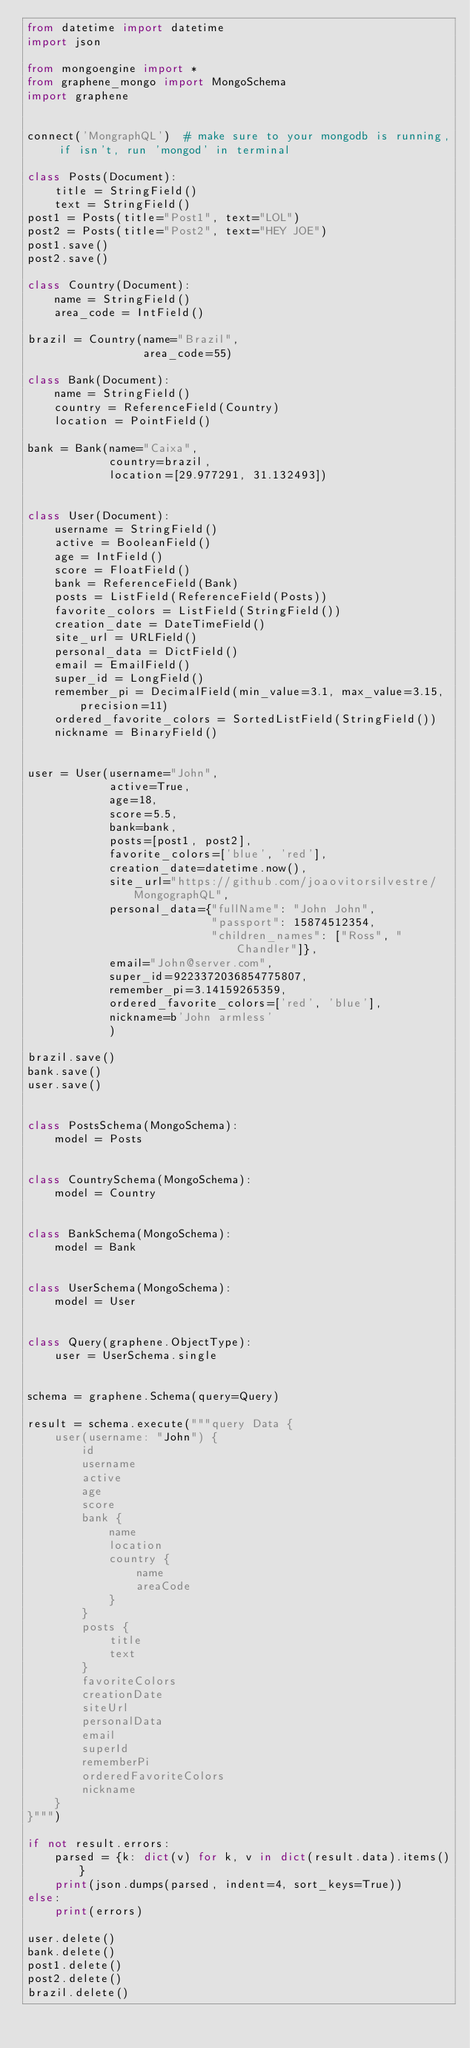Convert code to text. <code><loc_0><loc_0><loc_500><loc_500><_Python_>from datetime import datetime
import json

from mongoengine import *
from graphene_mongo import MongoSchema
import graphene


connect('MongraphQL')  # make sure to your mongodb is running, if isn't, run 'mongod' in terminal

class Posts(Document):
    title = StringField()
    text = StringField()
post1 = Posts(title="Post1", text="LOL")
post2 = Posts(title="Post2", text="HEY JOE")
post1.save()
post2.save()

class Country(Document):
    name = StringField()
    area_code = IntField()

brazil = Country(name="Brazil",
                 area_code=55)

class Bank(Document):
    name = StringField()
    country = ReferenceField(Country)
    location = PointField()

bank = Bank(name="Caixa",
            country=brazil,
            location=[29.977291, 31.132493])


class User(Document):
    username = StringField()
    active = BooleanField()
    age = IntField()
    score = FloatField()
    bank = ReferenceField(Bank)
    posts = ListField(ReferenceField(Posts))
    favorite_colors = ListField(StringField())
    creation_date = DateTimeField()
    site_url = URLField()
    personal_data = DictField()
    email = EmailField()
    super_id = LongField()
    remember_pi = DecimalField(min_value=3.1, max_value=3.15, precision=11)
    ordered_favorite_colors = SortedListField(StringField())
    nickname = BinaryField()


user = User(username="John",
            active=True,
            age=18,
            score=5.5,
            bank=bank,
            posts=[post1, post2],
            favorite_colors=['blue', 'red'],
            creation_date=datetime.now(),
            site_url="https://github.com/joaovitorsilvestre/MongographQL",
            personal_data={"fullName": "John John",
                           "passport": 15874512354,
                           "children_names": ["Ross", "Chandler"]},
            email="John@server.com",
            super_id=9223372036854775807,
            remember_pi=3.14159265359,
            ordered_favorite_colors=['red', 'blue'],
            nickname=b'John armless'
            )

brazil.save()
bank.save()
user.save()


class PostsSchema(MongoSchema):
    model = Posts


class CountrySchema(MongoSchema):
    model = Country


class BankSchema(MongoSchema):
    model = Bank


class UserSchema(MongoSchema):
    model = User


class Query(graphene.ObjectType):
    user = UserSchema.single


schema = graphene.Schema(query=Query)

result = schema.execute("""query Data {
    user(username: "John") {
        id
        username
        active
        age
        score
        bank {
            name
            location
            country {
                name
                areaCode
            }
        }
        posts {
            title
            text
        }
        favoriteColors
        creationDate
        siteUrl
        personalData
        email
        superId
        rememberPi
        orderedFavoriteColors
        nickname
    }
}""")

if not result.errors:
    parsed = {k: dict(v) for k, v in dict(result.data).items()}
    print(json.dumps(parsed, indent=4, sort_keys=True))
else:
    print(errors)

user.delete()
bank.delete()
post1.delete()
post2.delete()
brazil.delete()
</code> 